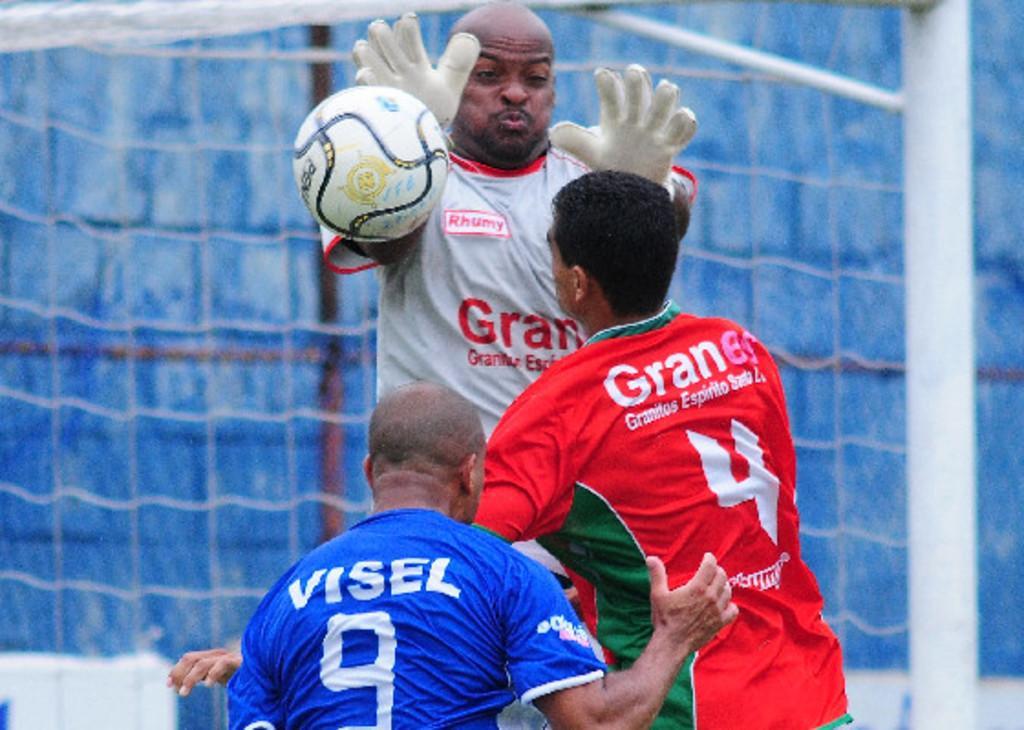Please provide a concise description of this image. This Picture describe about three football players. In front a man wearing white t- shirt and gloves is stopping the football from goal. Beside a man wearing red T- shirt is stopping him and another man wearing blue t- shirt on white Visel 9 is written. Behind we can see the white iron pole and goal post nets. 